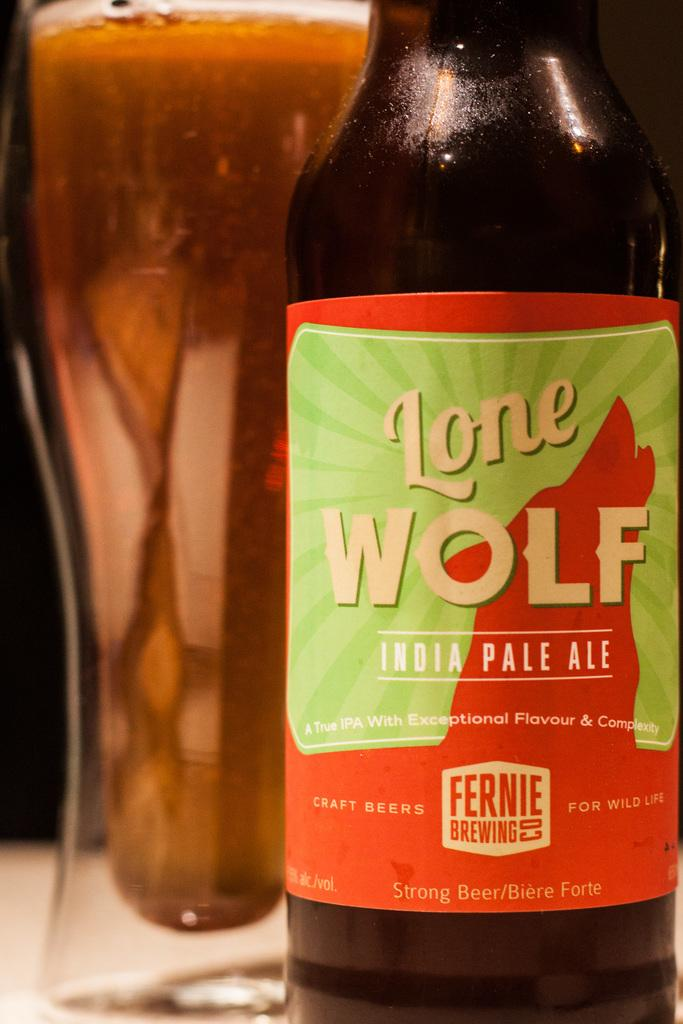<image>
Write a terse but informative summary of the picture. A full glass of beer is next to a bottle that says Lone Wolf India Pale Ale. 